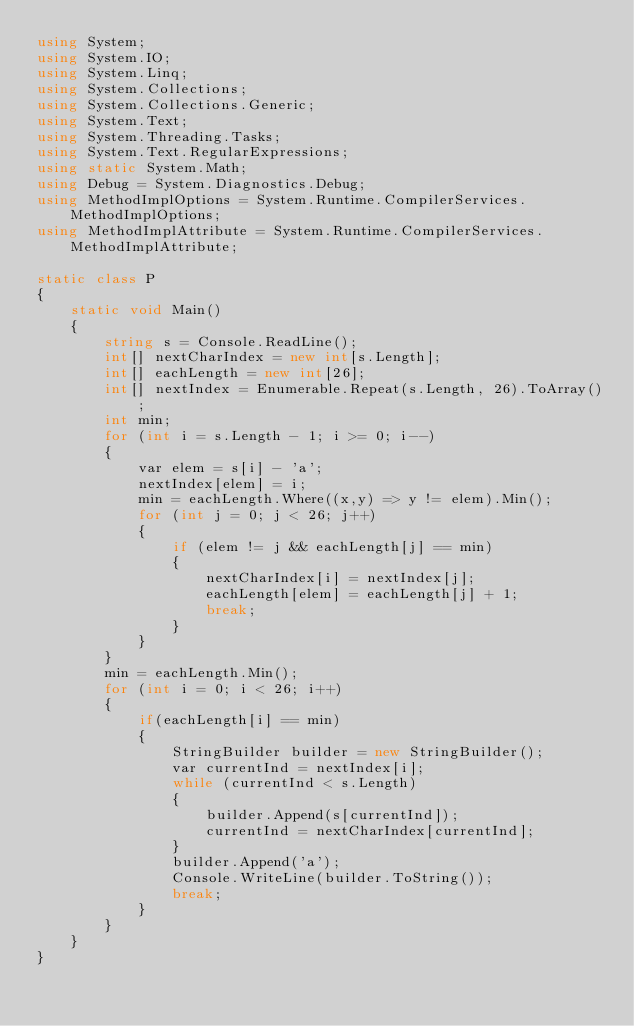Convert code to text. <code><loc_0><loc_0><loc_500><loc_500><_C#_>using System;
using System.IO;
using System.Linq;
using System.Collections;
using System.Collections.Generic;
using System.Text;
using System.Threading.Tasks;
using System.Text.RegularExpressions;
using static System.Math;
using Debug = System.Diagnostics.Debug;
using MethodImplOptions = System.Runtime.CompilerServices.MethodImplOptions;
using MethodImplAttribute = System.Runtime.CompilerServices.MethodImplAttribute;

static class P
{
    static void Main()
    {
        string s = Console.ReadLine();
        int[] nextCharIndex = new int[s.Length];
        int[] eachLength = new int[26];
        int[] nextIndex = Enumerable.Repeat(s.Length, 26).ToArray();
        int min;
        for (int i = s.Length - 1; i >= 0; i--)
        {
            var elem = s[i] - 'a';
            nextIndex[elem] = i;
            min = eachLength.Where((x,y) => y != elem).Min();
            for (int j = 0; j < 26; j++)
            {
                if (elem != j && eachLength[j] == min)
                {
                    nextCharIndex[i] = nextIndex[j];
                    eachLength[elem] = eachLength[j] + 1;
                    break;
                }
            }
        }
        min = eachLength.Min();
        for (int i = 0; i < 26; i++)
        {
            if(eachLength[i] == min)
            {
                StringBuilder builder = new StringBuilder();
                var currentInd = nextIndex[i];
                while (currentInd < s.Length)
                {
                    builder.Append(s[currentInd]);
                    currentInd = nextCharIndex[currentInd];
                }
                builder.Append('a');
                Console.WriteLine(builder.ToString());
                break;
            }
        }
    }
}
</code> 